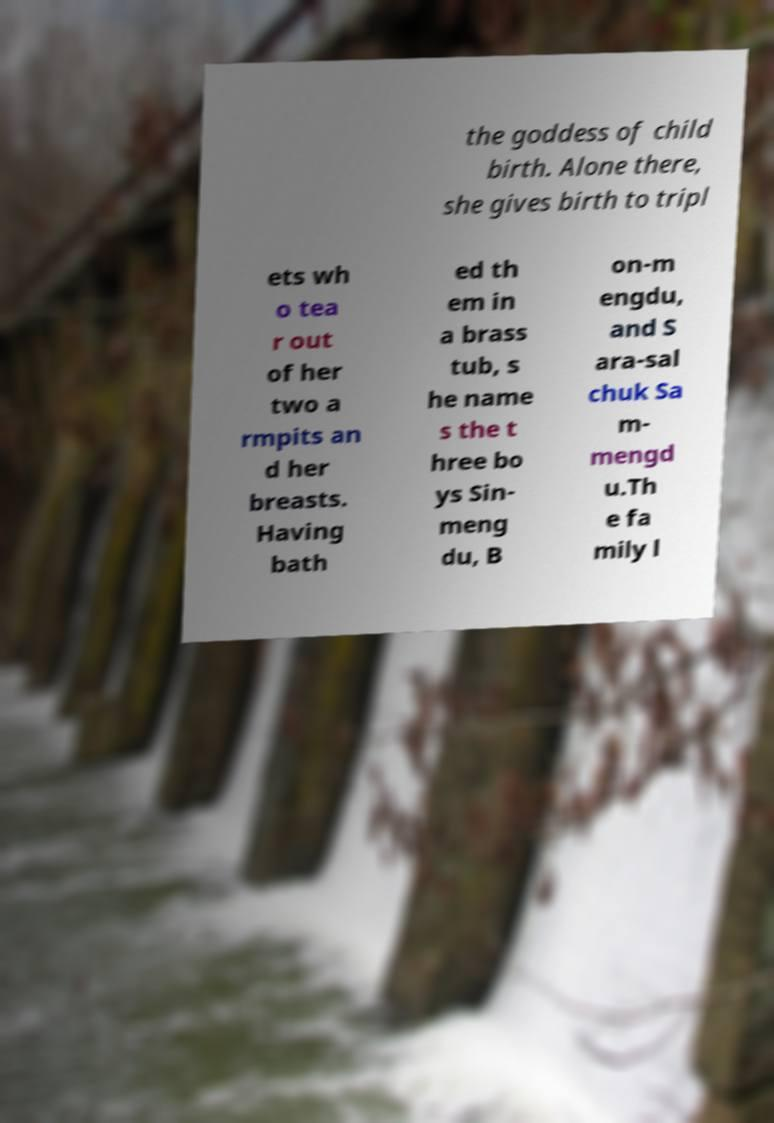Can you accurately transcribe the text from the provided image for me? the goddess of child birth. Alone there, she gives birth to tripl ets wh o tea r out of her two a rmpits an d her breasts. Having bath ed th em in a brass tub, s he name s the t hree bo ys Sin- meng du, B on-m engdu, and S ara-sal chuk Sa m- mengd u.Th e fa mily l 